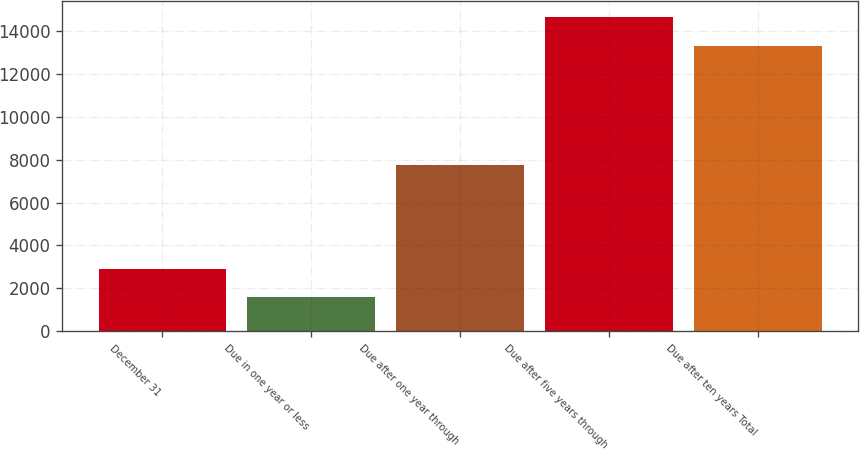Convert chart to OTSL. <chart><loc_0><loc_0><loc_500><loc_500><bar_chart><fcel>December 31<fcel>Due in one year or less<fcel>Due after one year through<fcel>Due after five years through<fcel>Due after ten years Total<nl><fcel>2881.8<fcel>1574<fcel>7738<fcel>14652<fcel>13303<nl></chart> 